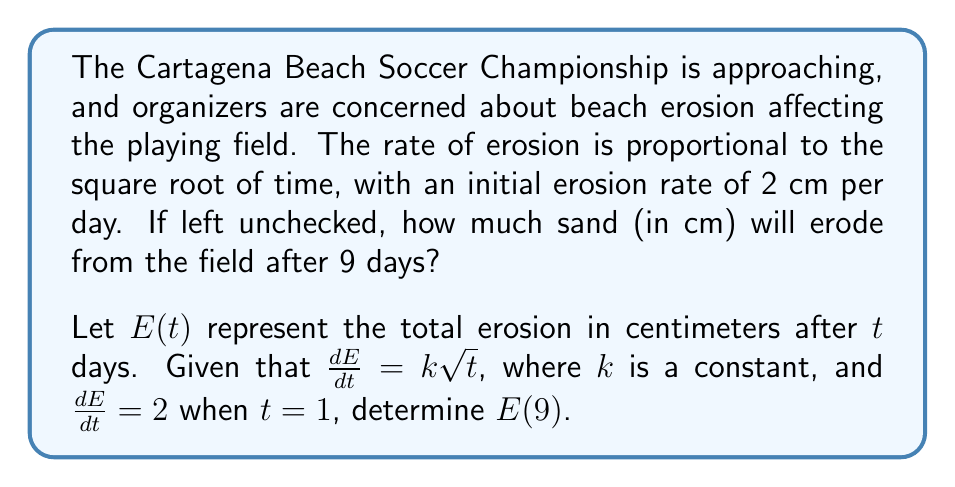Solve this math problem. Let's approach this step-by-step:

1) We're given that $\frac{dE}{dt} = k\sqrt{t}$, where $k$ is a constant.

2) We're also told that $\frac{dE}{dt} = 2$ when $t = 1$. Let's use this to find $k$:

   $2 = k\sqrt{1}$
   $2 = k$

3) Now we know our differential equation is $\frac{dE}{dt} = 2\sqrt{t}$

4) To find $E(t)$, we need to integrate both sides:

   $\int dE = \int 2\sqrt{t} dt$

5) Integrating the right side:

   $E = 2 \int \sqrt{t} dt = 2 \cdot \frac{2}{3}t^{3/2} + C = \frac{4}{3}t^{3/2} + C$

6) To find $C$, we can use the initial condition. When $t = 0$, $E = 0$:

   $0 = \frac{4}{3}(0)^{3/2} + C$
   $C = 0$

7) Therefore, our erosion function is:

   $E(t) = \frac{4}{3}t^{3/2}$

8) To find the erosion after 9 days, we calculate $E(9)$:

   $E(9) = \frac{4}{3}(9)^{3/2} = \frac{4}{3} \cdot 27 = 36$

Therefore, after 9 days, 36 cm of sand will have eroded from the field.
Answer: $E(9) = 36$ cm 